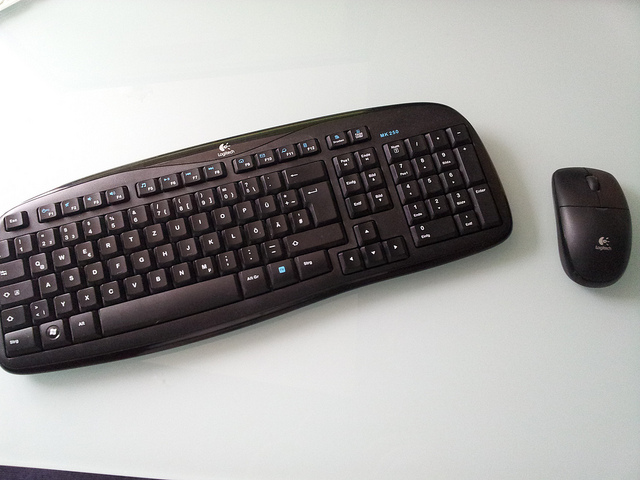Please extract the text content from this image. R O 5 U V I G P 0 J K 4 N B H 1 T Z X 0 D Q W 8 A 